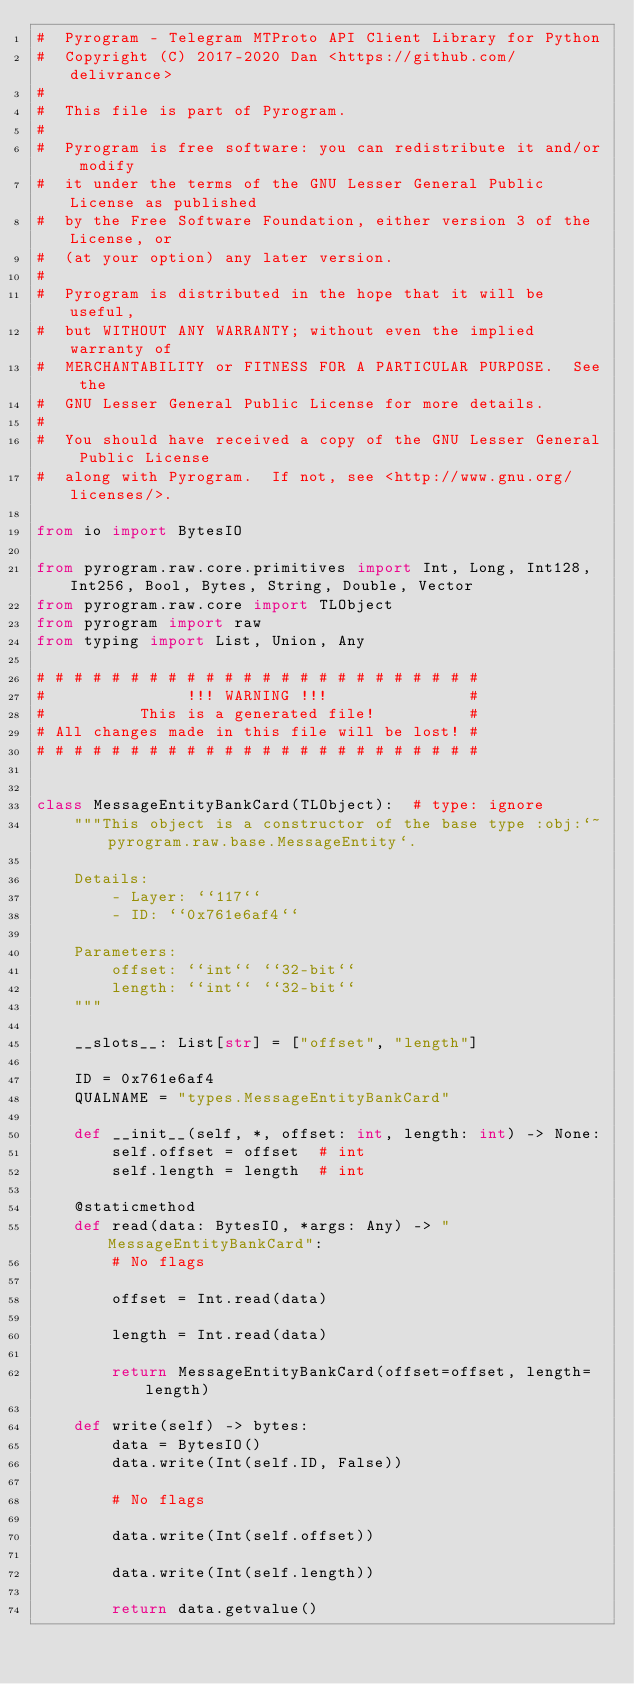Convert code to text. <code><loc_0><loc_0><loc_500><loc_500><_Python_>#  Pyrogram - Telegram MTProto API Client Library for Python
#  Copyright (C) 2017-2020 Dan <https://github.com/delivrance>
#
#  This file is part of Pyrogram.
#
#  Pyrogram is free software: you can redistribute it and/or modify
#  it under the terms of the GNU Lesser General Public License as published
#  by the Free Software Foundation, either version 3 of the License, or
#  (at your option) any later version.
#
#  Pyrogram is distributed in the hope that it will be useful,
#  but WITHOUT ANY WARRANTY; without even the implied warranty of
#  MERCHANTABILITY or FITNESS FOR A PARTICULAR PURPOSE.  See the
#  GNU Lesser General Public License for more details.
#
#  You should have received a copy of the GNU Lesser General Public License
#  along with Pyrogram.  If not, see <http://www.gnu.org/licenses/>.

from io import BytesIO

from pyrogram.raw.core.primitives import Int, Long, Int128, Int256, Bool, Bytes, String, Double, Vector
from pyrogram.raw.core import TLObject
from pyrogram import raw
from typing import List, Union, Any

# # # # # # # # # # # # # # # # # # # # # # # #
#               !!! WARNING !!!               #
#          This is a generated file!          #
# All changes made in this file will be lost! #
# # # # # # # # # # # # # # # # # # # # # # # #


class MessageEntityBankCard(TLObject):  # type: ignore
    """This object is a constructor of the base type :obj:`~pyrogram.raw.base.MessageEntity`.

    Details:
        - Layer: ``117``
        - ID: ``0x761e6af4``

    Parameters:
        offset: ``int`` ``32-bit``
        length: ``int`` ``32-bit``
    """

    __slots__: List[str] = ["offset", "length"]

    ID = 0x761e6af4
    QUALNAME = "types.MessageEntityBankCard"

    def __init__(self, *, offset: int, length: int) -> None:
        self.offset = offset  # int
        self.length = length  # int

    @staticmethod
    def read(data: BytesIO, *args: Any) -> "MessageEntityBankCard":
        # No flags
        
        offset = Int.read(data)
        
        length = Int.read(data)
        
        return MessageEntityBankCard(offset=offset, length=length)

    def write(self) -> bytes:
        data = BytesIO()
        data.write(Int(self.ID, False))

        # No flags
        
        data.write(Int(self.offset))
        
        data.write(Int(self.length))
        
        return data.getvalue()
</code> 